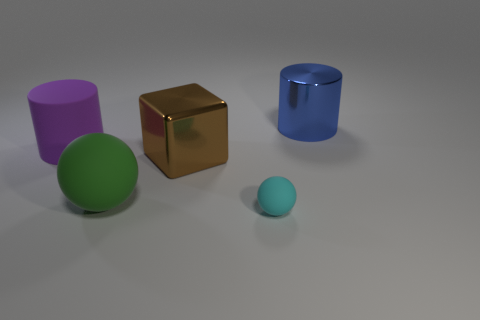Are there any other things that are the same shape as the big brown thing?
Your answer should be compact. No. There is a cylinder that is left of the large blue cylinder; is its size the same as the metal object in front of the blue metallic cylinder?
Provide a succinct answer. Yes. Does the brown cube have the same size as the cylinder on the right side of the large green ball?
Keep it short and to the point. Yes. What is the size of the rubber thing left of the large matte object that is in front of the brown metal object?
Give a very brief answer. Large. What color is the big thing that is the same shape as the tiny cyan matte thing?
Keep it short and to the point. Green. Does the purple matte cylinder have the same size as the block?
Ensure brevity in your answer.  Yes. Are there the same number of cubes in front of the green ball and small cyan matte objects?
Offer a terse response. No. Are there any metal blocks that are in front of the large cylinder that is to the right of the small cyan sphere?
Offer a terse response. Yes. There is a cylinder that is to the left of the big metallic thing that is right of the object in front of the big sphere; what is its size?
Ensure brevity in your answer.  Large. The cylinder on the left side of the big shiny object that is in front of the big blue metallic object is made of what material?
Keep it short and to the point. Rubber. 